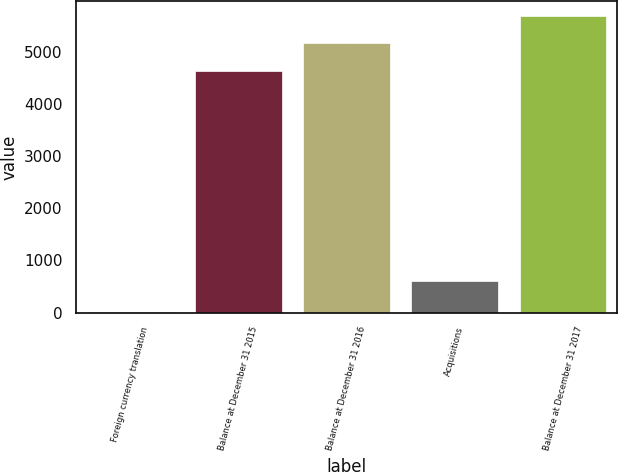Convert chart. <chart><loc_0><loc_0><loc_500><loc_500><bar_chart><fcel>Foreign currency translation<fcel>Balance at December 31 2015<fcel>Balance at December 31 2016<fcel>Acquisitions<fcel>Balance at December 31 2017<nl><fcel>3<fcel>4638<fcel>5164.2<fcel>612<fcel>5690.4<nl></chart> 